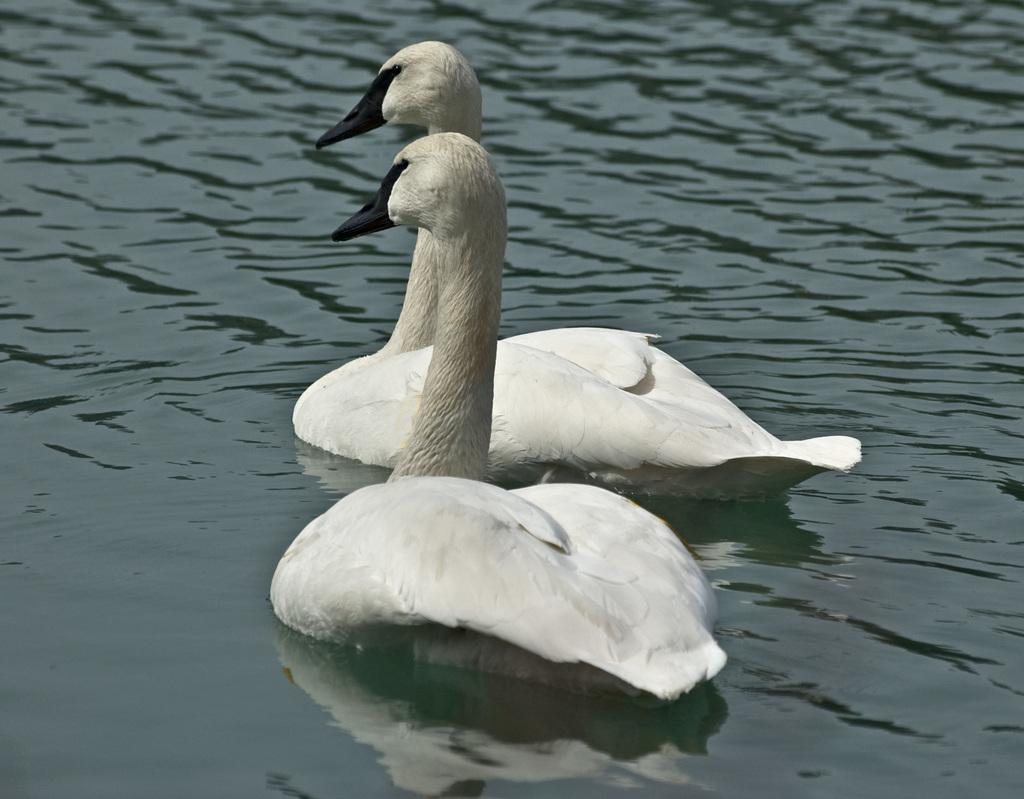What animals are in the foreground of the image? There are two ducks in the foreground of the image. Where are the ducks located? The ducks are in the water. What type of hat is the duck wearing in the image? There is no hat present on the ducks in the image. What kind of paper can be seen floating near the ducks? There is no paper visible in the image; it only features two ducks in the water. 